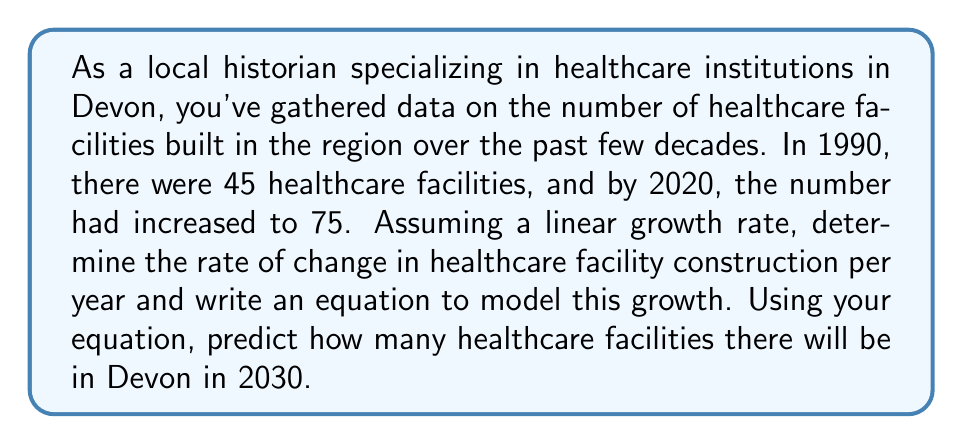What is the answer to this math problem? To solve this problem, we'll use the linear equation model:

$$ y = mx + b $$

Where:
$y$ is the number of healthcare facilities
$m$ is the rate of change (slope)
$x$ is the number of years since 1990
$b$ is the initial number of facilities in 1990

Step 1: Calculate the rate of change (slope)
$$ m = \frac{y_2 - y_1}{x_2 - x_1} = \frac{75 - 45}{2020 - 1990} = \frac{30}{30} = 1 $$

The rate of change is 1 facility per year.

Step 2: Write the equation
We know $b = 45$ (the number of facilities in 1990), so our equation is:

$$ y = 1x + 45 $$

Step 3: Predict the number of facilities in 2030
To find this, we need to calculate $x$ for 2030:
$x = 2030 - 1990 = 40$

Now we can plug this into our equation:

$$ y = 1(40) + 45 = 85 $$

Therefore, in 2030, there will be 85 healthcare facilities in Devon.
Answer: The rate of change in healthcare facility construction is 1 facility per year. The linear equation modeling this growth is $y = 1x + 45$, where $x$ is the number of years since 1990. In 2030, there will be 85 healthcare facilities in Devon. 